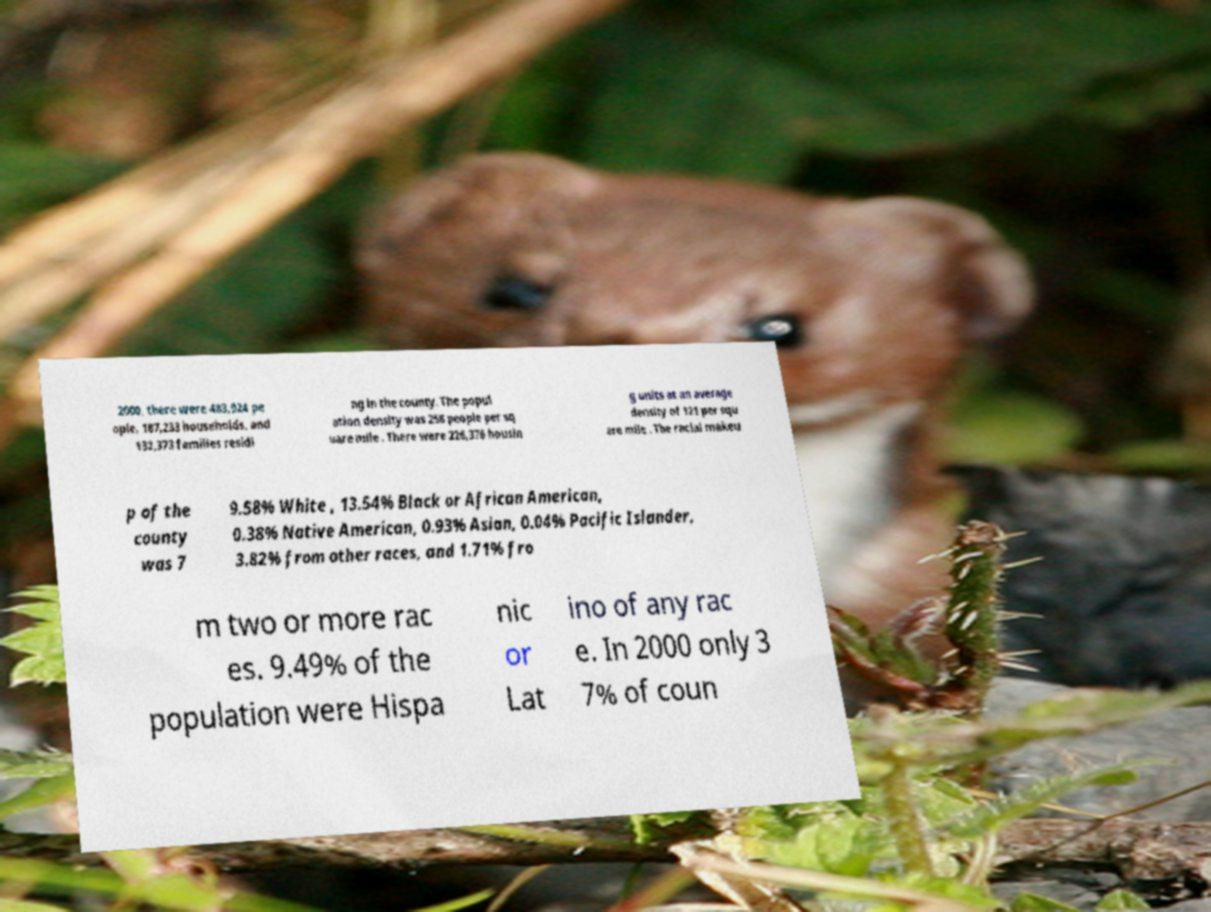There's text embedded in this image that I need extracted. Can you transcribe it verbatim? 2000, there were 483,924 pe ople, 187,233 households, and 132,373 families residi ng in the county. The popul ation density was 258 people per sq uare mile . There were 226,376 housin g units at an average density of 121 per squ are mile . The racial makeu p of the county was 7 9.58% White , 13.54% Black or African American, 0.38% Native American, 0.93% Asian, 0.04% Pacific Islander, 3.82% from other races, and 1.71% fro m two or more rac es. 9.49% of the population were Hispa nic or Lat ino of any rac e. In 2000 only 3 7% of coun 